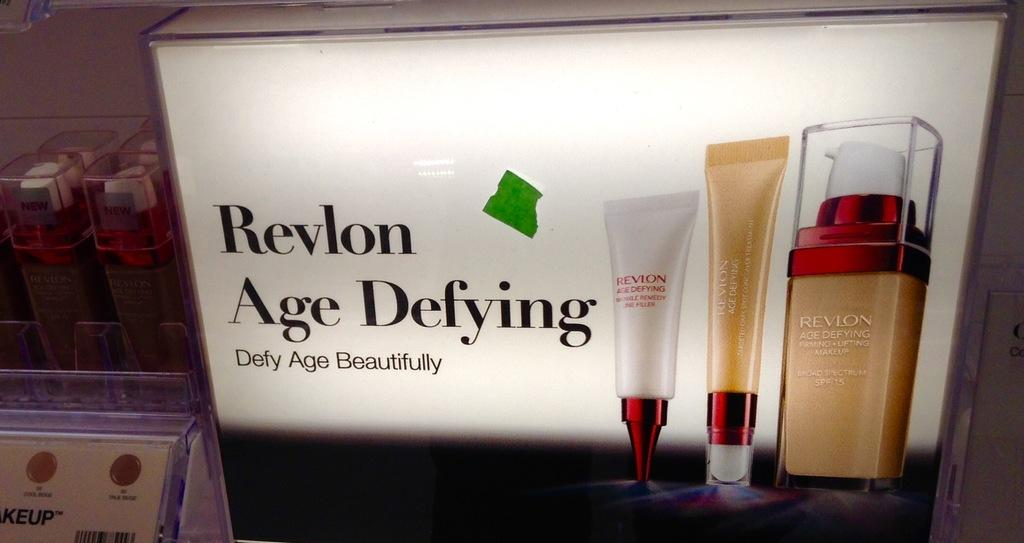<image>
Present a compact description of the photo's key features. An ad for Revlon Age Defying makeup with foundation bottles and concealers 